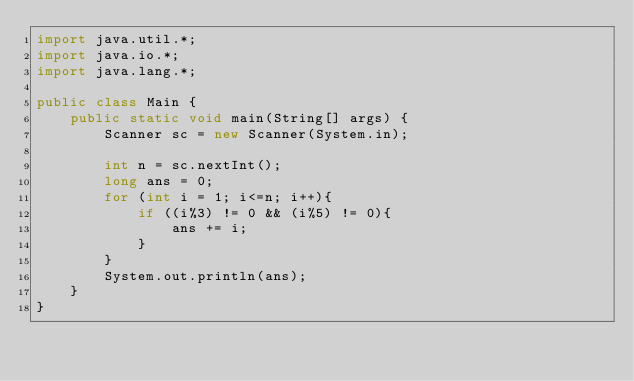<code> <loc_0><loc_0><loc_500><loc_500><_Java_>import java.util.*;
import java.io.*;
import java.lang.*;

public class Main {
    public static void main(String[] args) {
        Scanner sc = new Scanner(System.in);

        int n = sc.nextInt();
        long ans = 0;
        for (int i = 1; i<=n; i++){
            if ((i%3) != 0 && (i%5) != 0){
                ans += i;
            }
        }
        System.out.println(ans);
    }
}</code> 